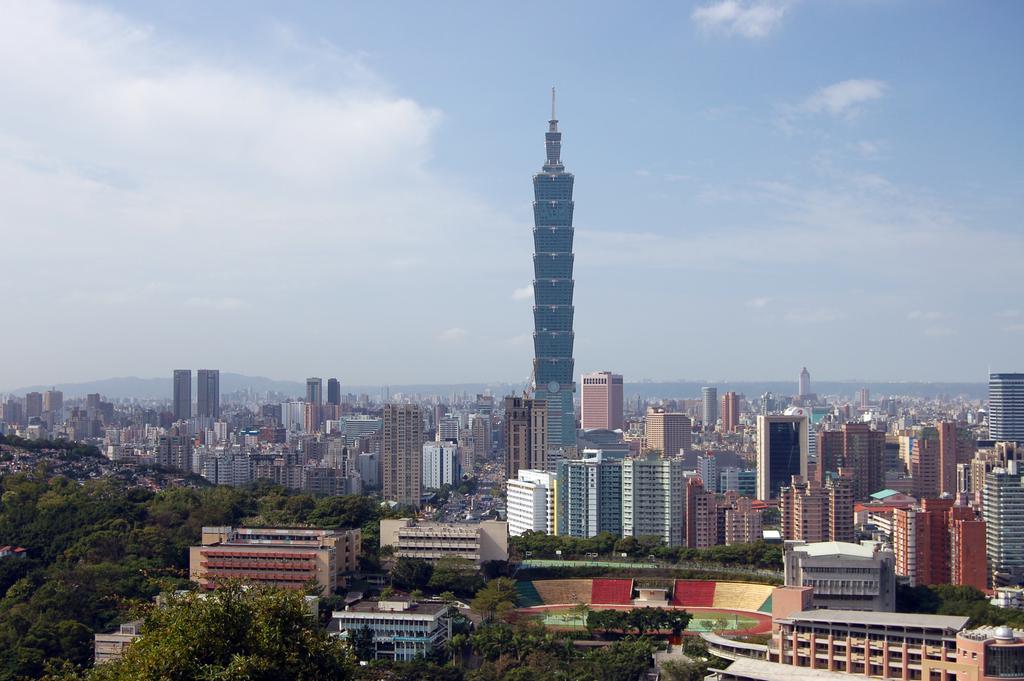In one or two sentences, can you explain what this image depicts? Here in this picture, in the middle we can see a clock tower present and we can see other buildings and houses present all over there and we can see trees and plants here and there and we can see clouds in sky. 